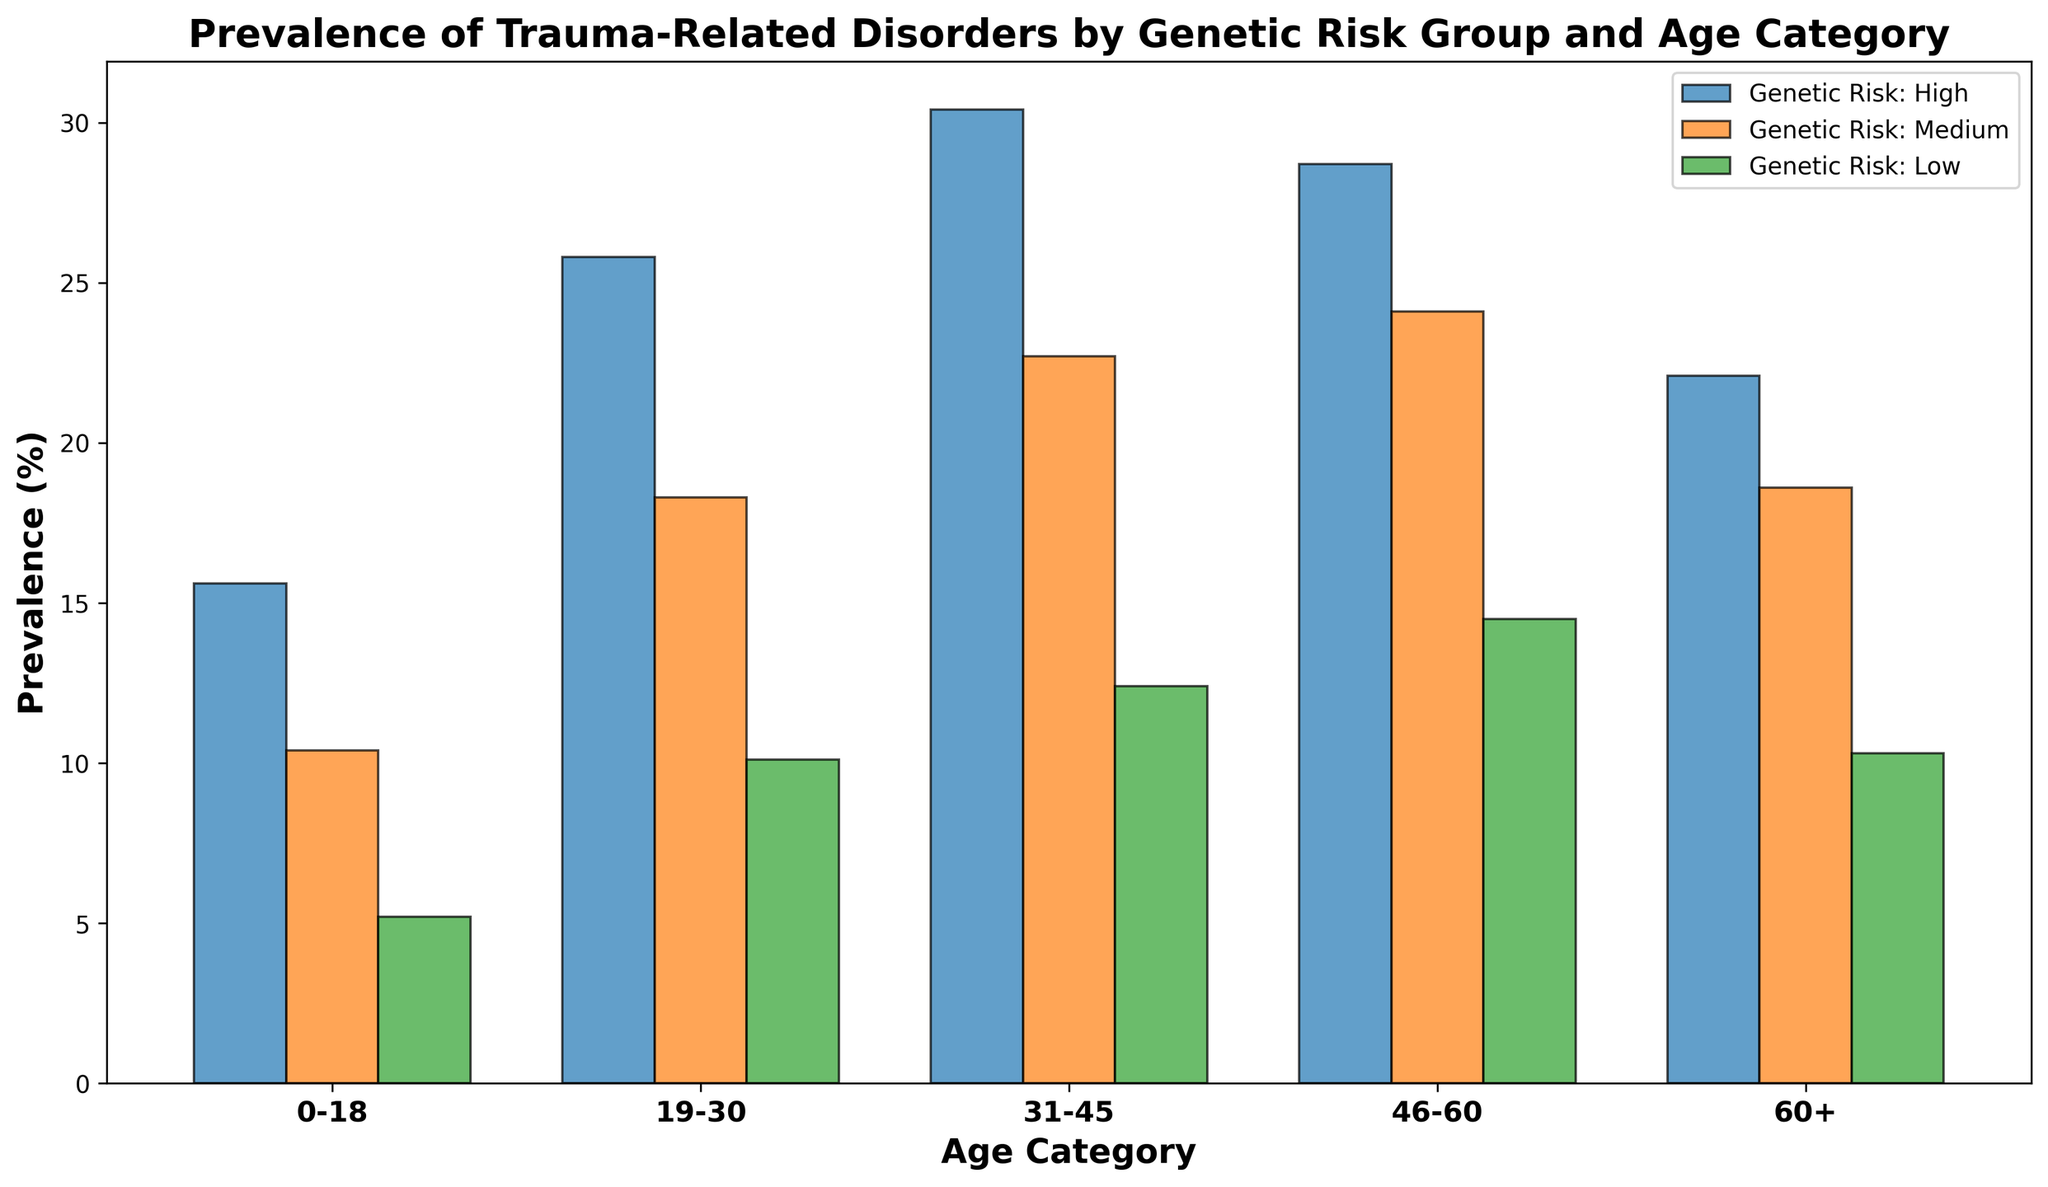What's the prevalence of trauma-related disorders for the High genetic risk group in the 31-45 age category? Look at the bar corresponding to the High genetic risk group and the 31-45 age category. Read the height of the bar.
Answer: 30.4% Among all genetic risk groups, which has the lowest prevalence in the 19-30 age category? Compare the bars for the 19-30 age category across all genetic risk groups. Identify the lowest bar visually.
Answer: Low Which genetic risk group shows the highest prevalence of trauma-related disorders in the 60+ age category? Look at the bars for the 60+ age category and identify which bar is the highest. This will be the genetic risk group with the highest prevalence.
Answer: High How does the prevalence of trauma-related disorders change from the 0-18 to the 31-45 age category for the Medium genetic risk group? Identify the bars corresponding to the Medium genetic risk group for the 0-18 and 31-45 age categories. Note their heights and compare them to see the change.
Answer: Increases from 10.4% to 22.7% What is the difference in prevalence between the High and Low genetic risk groups in the 46-60 age category? Find the heights of the bars for the High and Low genetic risk groups in the 46-60 age category. Subtract the Low value from the High value.
Answer: 28.7% - 14.5% = 14.2% Is the prevalence of trauma-related disorders in the Medium genetic risk group higher than in the Low genetic risk group across all age categories? Compare the heights of the bars for the Medium and Low genetic risk groups in each age category to see if the Medium group is consistently higher.
Answer: Yes What is the average prevalence of trauma-related disorders in the High genetic risk group across all age categories? Add the prevalence values for the High genetic risk group for all age categories and then divide by the number of categories.
Answer: (15.6 + 25.8 + 30.4 + 28.7 + 22.1) / 5 = 24.52% Which age category shows the most significant increase in prevalence from the Low to High genetic risk group? For each age category, subtract the Low group's prevalence from the High group's prevalence, and identify which age category has the largest difference.
Answer: 31-45 (30.4% - 12.4% = 18%) Does the prevalence of trauma-related disorders in the Low genetic risk group exceed 15% in any age category? Check the heights of all the bars for the Low genetic risk group to see if any of them are above 15%.
Answer: No What is the total prevalence of trauma-related disorders for the Medium genetic risk group across all age categories? Sum the prevalence values for the Medium genetic risk group across all age categories.
Answer: 10.4 + 18.3 + 22.7 + 24.1 + 18.6 = 94.1% 